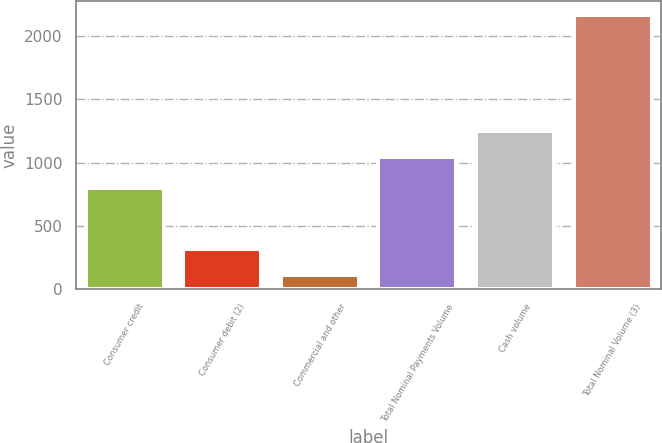Convert chart to OTSL. <chart><loc_0><loc_0><loc_500><loc_500><bar_chart><fcel>Consumer credit<fcel>Consumer debit (2)<fcel>Commercial and other<fcel>Total Nominal Payments Volume<fcel>Cash volume<fcel>Total Nominal Volume (3)<nl><fcel>802<fcel>314.2<fcel>108<fcel>1043<fcel>1249.2<fcel>2170<nl></chart> 